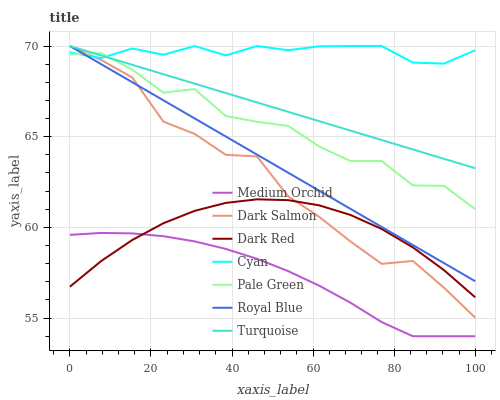Does Medium Orchid have the minimum area under the curve?
Answer yes or no. Yes. Does Cyan have the maximum area under the curve?
Answer yes or no. Yes. Does Dark Red have the minimum area under the curve?
Answer yes or no. No. Does Dark Red have the maximum area under the curve?
Answer yes or no. No. Is Royal Blue the smoothest?
Answer yes or no. Yes. Is Pale Green the roughest?
Answer yes or no. Yes. Is Dark Red the smoothest?
Answer yes or no. No. Is Dark Red the roughest?
Answer yes or no. No. Does Medium Orchid have the lowest value?
Answer yes or no. Yes. Does Dark Red have the lowest value?
Answer yes or no. No. Does Cyan have the highest value?
Answer yes or no. Yes. Does Dark Red have the highest value?
Answer yes or no. No. Is Medium Orchid less than Pale Green?
Answer yes or no. Yes. Is Cyan greater than Dark Red?
Answer yes or no. Yes. Does Turquoise intersect Cyan?
Answer yes or no. Yes. Is Turquoise less than Cyan?
Answer yes or no. No. Is Turquoise greater than Cyan?
Answer yes or no. No. Does Medium Orchid intersect Pale Green?
Answer yes or no. No. 